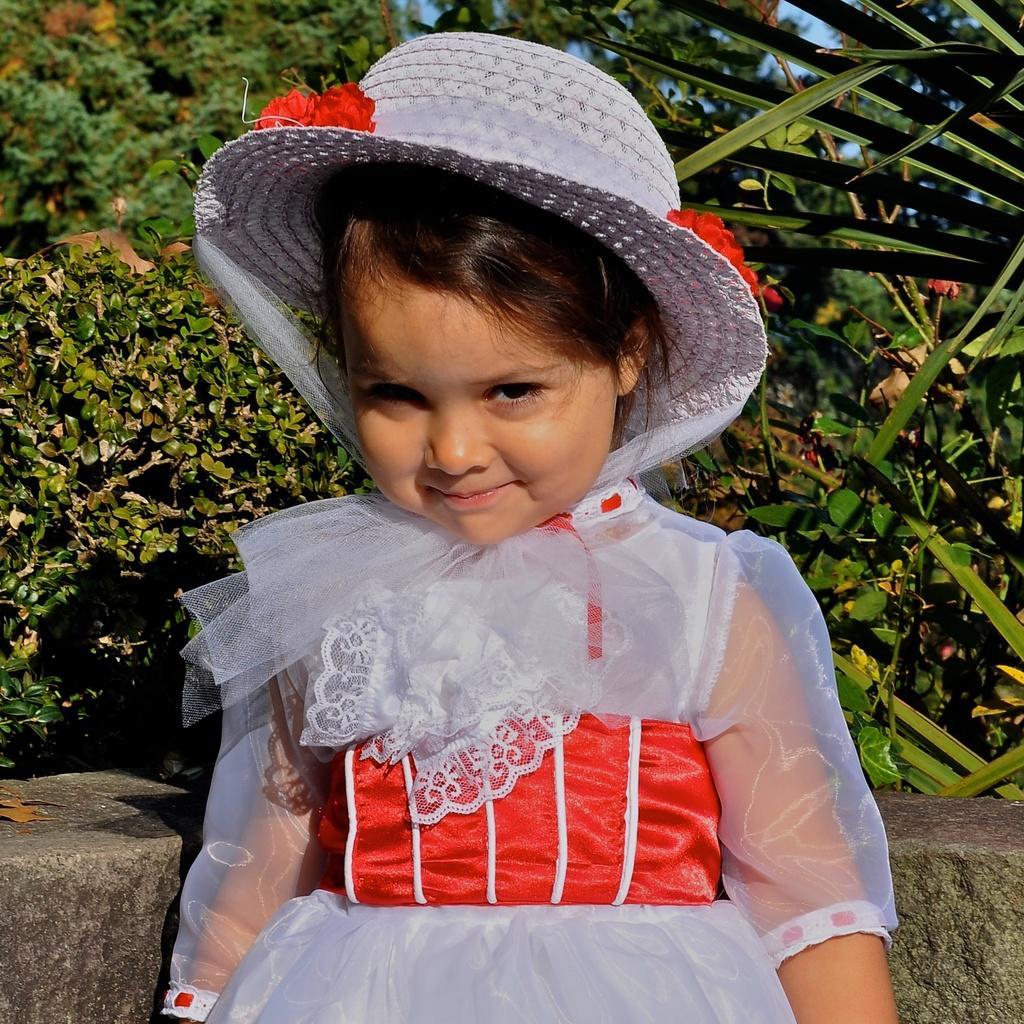In one or two sentences, can you explain what this image depicts? In this picture I can see a girl standing, she is wearing a cap and I can see few trees in the back and a blue sky. 